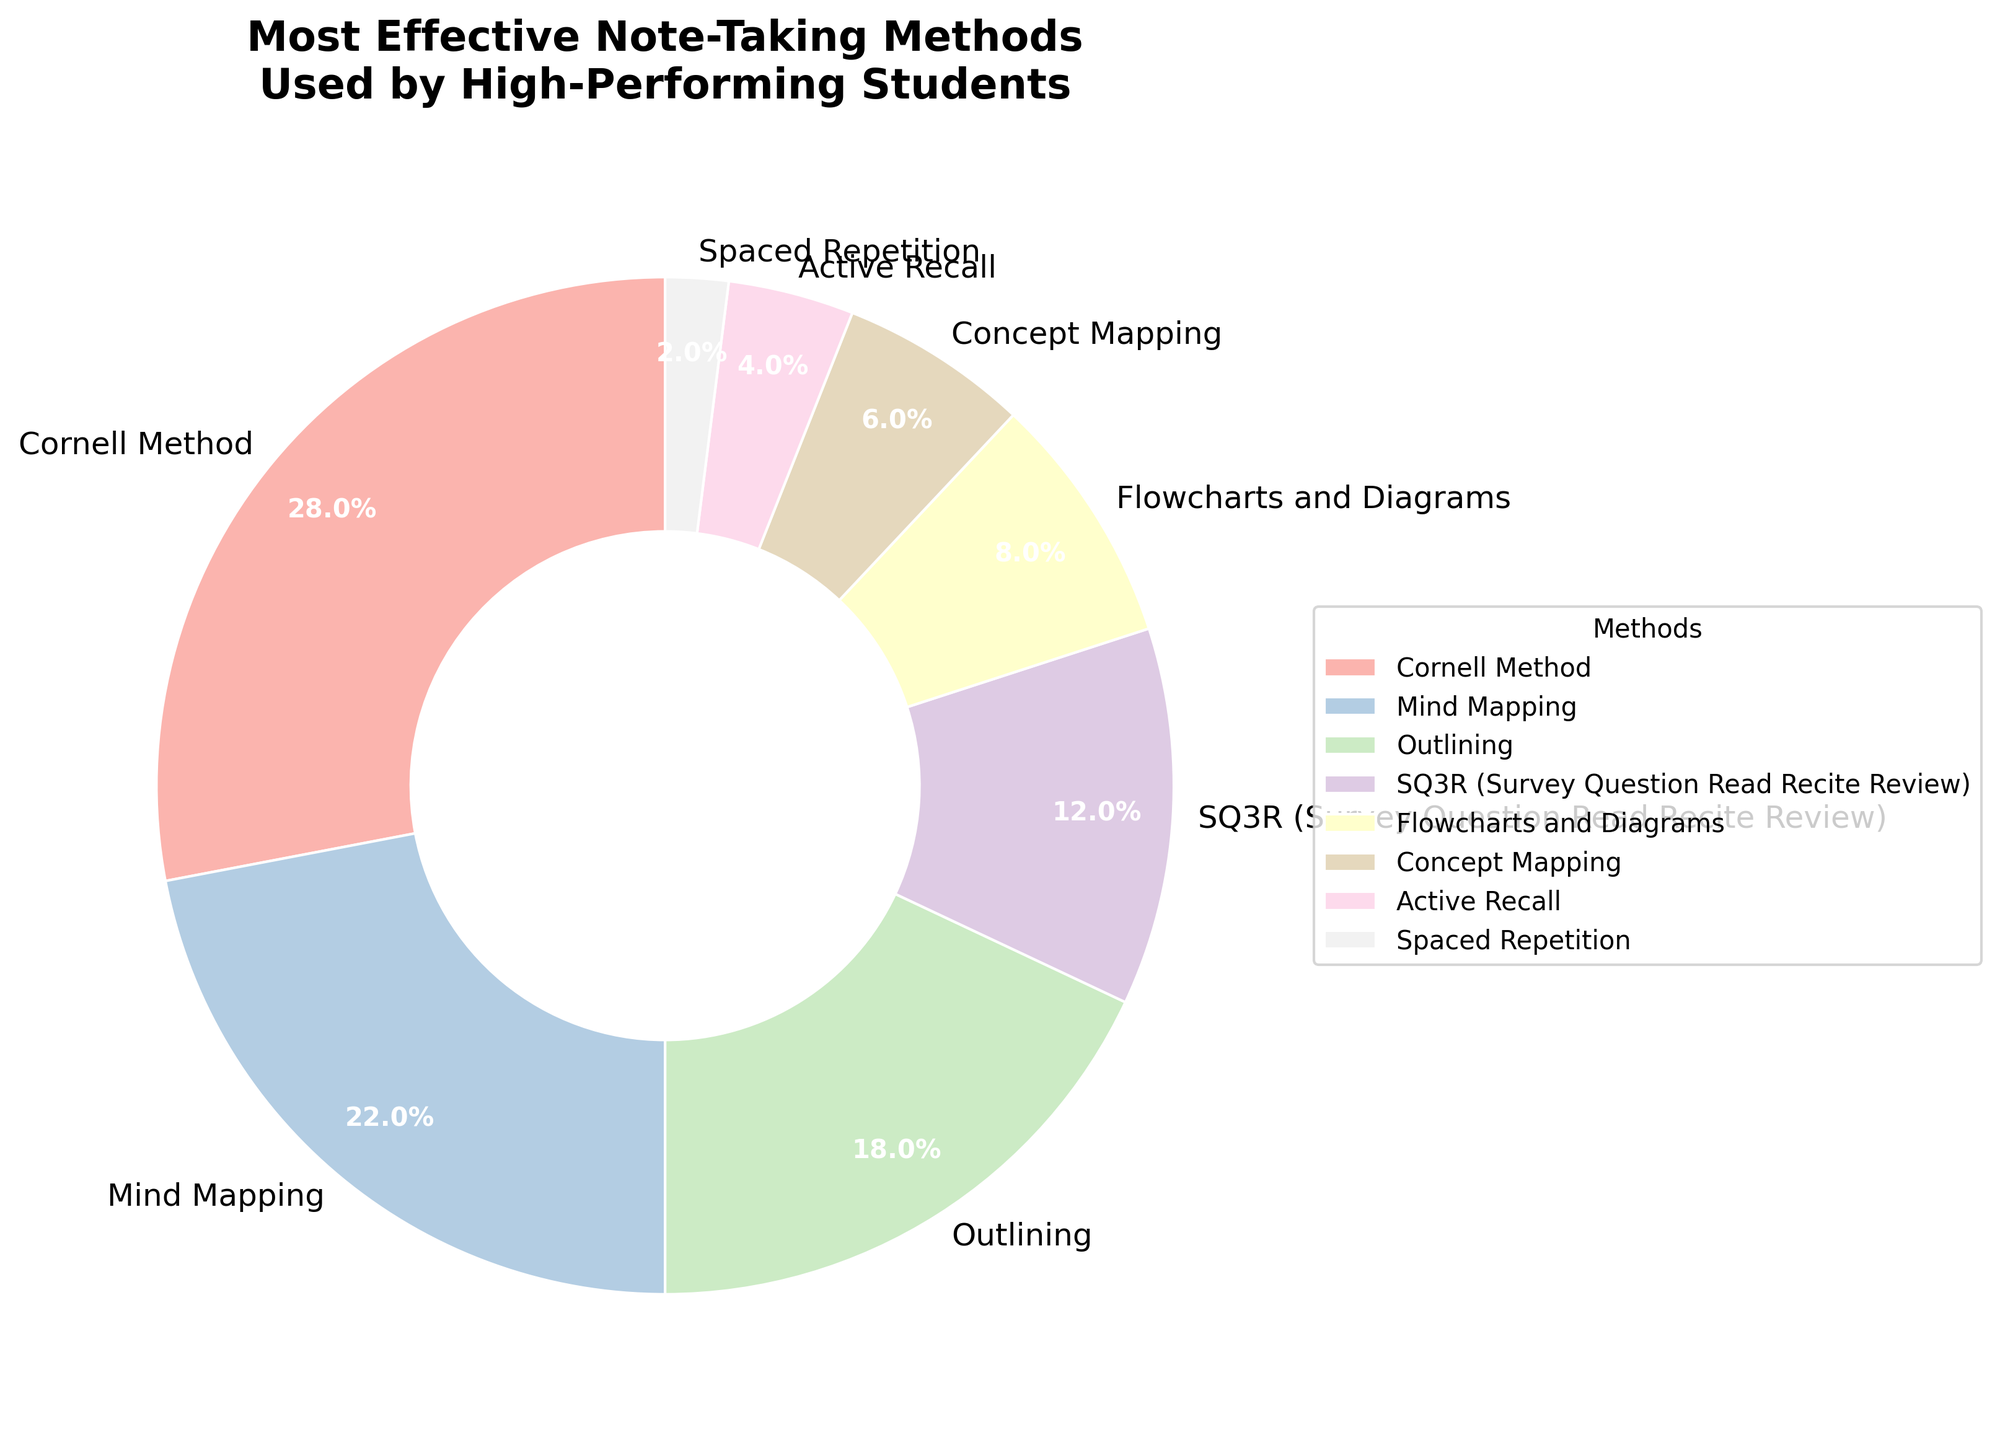What percentage of students used the Cornell Method compared to those using Mind Mapping? The percentage of students using the Cornell Method is 28%, whereas those using Mind Mapping are 22%. A comparison indicates that a greater percentage of students use the Cornell Method.
Answer: Cornell Method: 28%, Mind Mapping: 22% What is the total percentage of students using Outlining and SQ3R methods? Add the percentages of students using Outlining (18%) and SQ3R (12%). The total is 18% + 12% = 30%.
Answer: 30% Which note-taking method has the lowest usage percentage among high-performing students? The method with the lowest usage percentage among high-performing students is Spaced Repetition, which accounts for 2%.
Answer: Spaced Repetition: 2% How many note-taking methods have a percentage usage of 10% or higher? The methods with 10% or higher usage are Cornell Method (28%), Mind Mapping (22%), Outlining (18%), and SQ3R (12%). This sums up to 4 methods.
Answer: 4 methods Is the combined percentage of students using Flowcharts and Diagrams, and Concept Mapping greater than those using the SQ3R method? The combined percentage of Flowcharts and Diagrams (8%) and Concept Mapping (6%) is 8% + 6% = 14%, which is greater than the 12% of students using the SQ3R method.
Answer: Yes What proportion of the pie chart is covered by methods related to visual learning (Mind Mapping, Flowcharts and Diagrams, Concept Mapping)? The visual learning methods include Mind Mapping (22%), Flowcharts and Diagrams (8%), and Concept Mapping (6%). Adding these gives 22% + 8% + 6% = 36%.
Answer: 36% Which method shows up in a pastel pink color in the pie chart? While this exact color detail isn't specified, in a typical pastel color scheme, the Cornell Method is likely depicted in pastel pink as it is the largest segment and often gets a more prominent color.
Answer: Cornell Method What is the difference in percentage points between the most popular and least popular note-taking methods? The most popular method is the Cornell Method at 28%, and the least popular is Spaced Repetition at 2%. The difference is 28% - 2% = 26%.
Answer: 26% What's the sum percentage of Active Recall and Spaced Repetition methods? Add the percentages of Active Recall (4%) and Spaced Repetition (2%). The sum is 4% + 2% = 6%.
Answer: 6% If you combine the percentages of the top three most used methods, what fraction of the total chart do they cover? The top three most used methods are Cornell Method (28%), Mind Mapping (22%), and Outlining (18%). Their combined percentage is 28% + 22% + 18% = 68%. This can be expressed as the fraction 68/100 or simplified to 34/50.
Answer: 34/50 